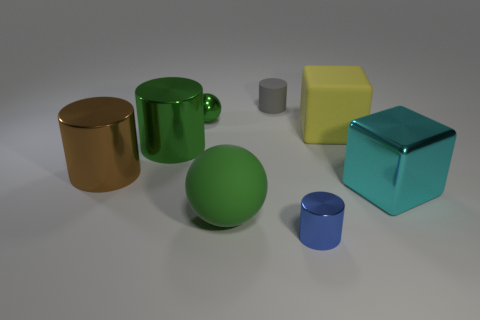What shape is the matte object that is the same color as the metallic sphere?
Keep it short and to the point. Sphere. Is there a yellow thing that has the same shape as the small gray thing?
Give a very brief answer. No. What is the color of the rubber block that is the same size as the green rubber object?
Your response must be concise. Yellow. What color is the small object that is to the left of the tiny cylinder behind the green metallic sphere?
Provide a succinct answer. Green. There is a metal object behind the large green cylinder; is its color the same as the large sphere?
Offer a very short reply. Yes. There is a blue shiny thing that is in front of the tiny cylinder that is behind the large green thing that is in front of the brown metal cylinder; what shape is it?
Offer a very short reply. Cylinder. There is a large green object that is behind the big cyan metal thing; how many brown metallic objects are to the right of it?
Provide a short and direct response. 0. Is the material of the large cyan cube the same as the tiny blue thing?
Give a very brief answer. Yes. How many large green rubber things are on the right side of the large green shiny thing that is on the left side of the shiny cylinder that is on the right side of the green shiny ball?
Your answer should be compact. 1. There is a tiny object in front of the green rubber thing; what is its color?
Give a very brief answer. Blue. 